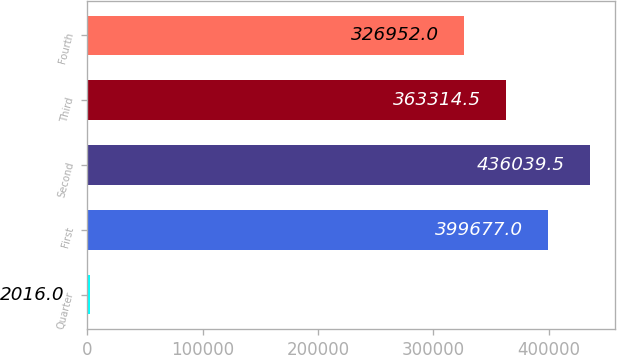Convert chart to OTSL. <chart><loc_0><loc_0><loc_500><loc_500><bar_chart><fcel>Quarter<fcel>First<fcel>Second<fcel>Third<fcel>Fourth<nl><fcel>2016<fcel>399677<fcel>436040<fcel>363314<fcel>326952<nl></chart> 